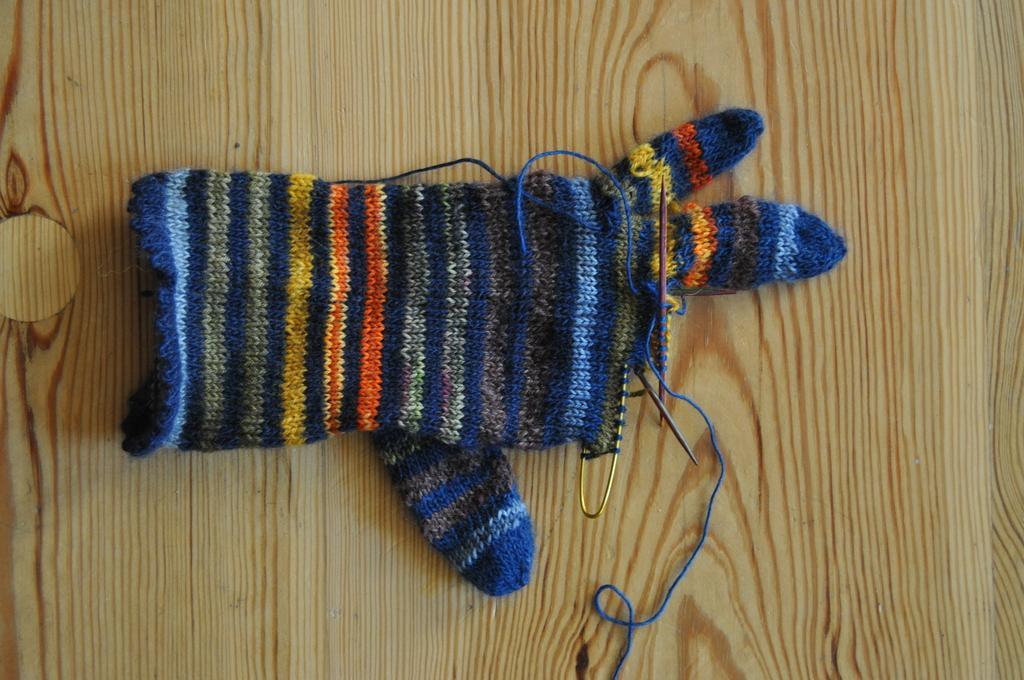Please provide a concise description of this image. In the image we can see there is an unstitched woollen hand glove kept on the table. There are sewing pin kept on the woollen hand glove. 